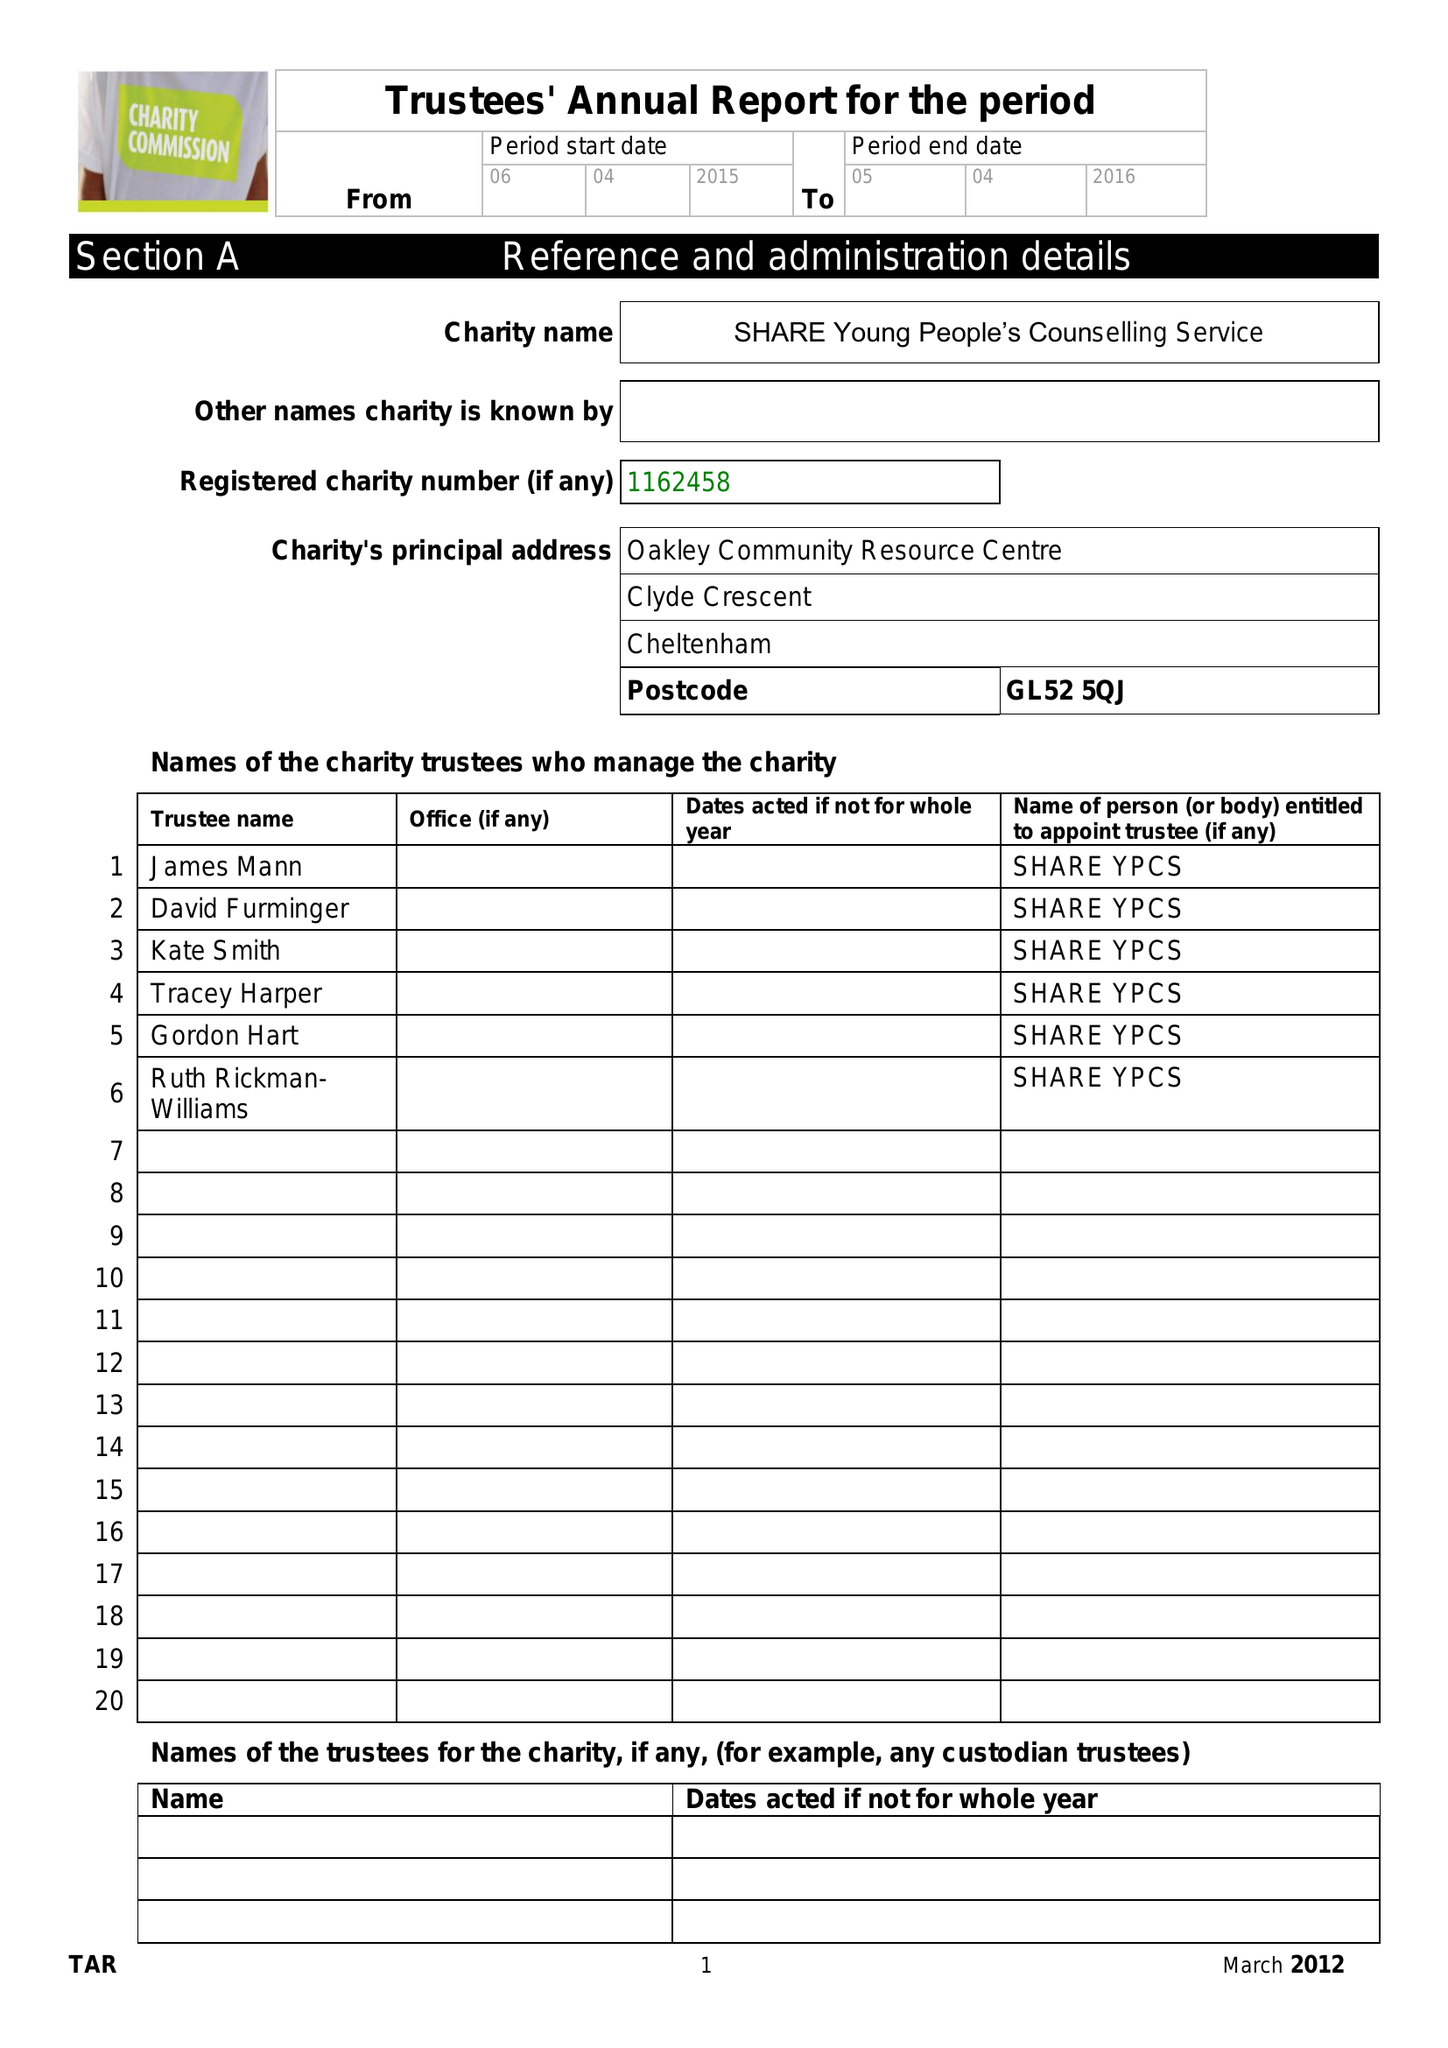What is the value for the report_date?
Answer the question using a single word or phrase. 2016-04-05 